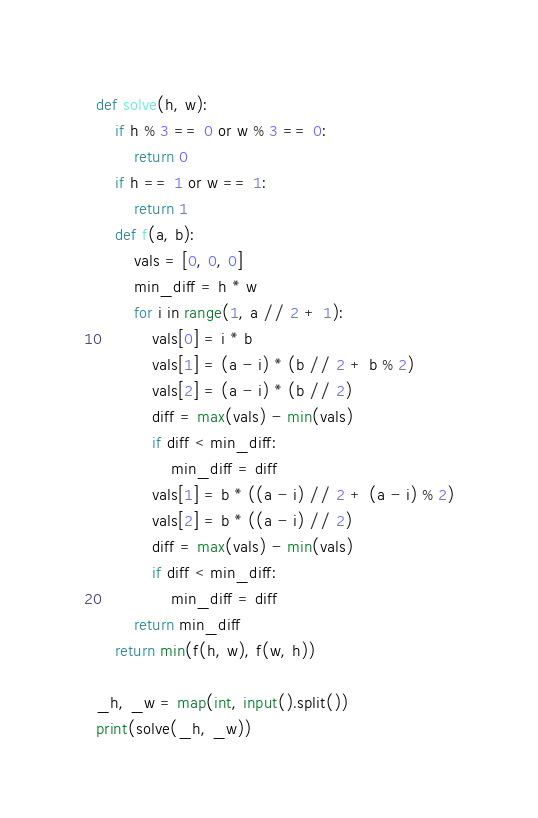<code> <loc_0><loc_0><loc_500><loc_500><_Python_>def solve(h, w):
    if h % 3 == 0 or w % 3 == 0:
        return 0
    if h == 1 or w == 1:
        return 1
    def f(a, b):
        vals = [0, 0, 0]
        min_diff = h * w
        for i in range(1, a // 2 + 1):
            vals[0] = i * b
            vals[1] = (a - i) * (b // 2 + b % 2)
            vals[2] = (a - i) * (b // 2)
            diff = max(vals) - min(vals)
            if diff < min_diff:
                min_diff = diff
            vals[1] = b * ((a - i) // 2 + (a - i) % 2)
            vals[2] = b * ((a - i) // 2)
            diff = max(vals) - min(vals)
            if diff < min_diff:
                min_diff = diff
        return min_diff
    return min(f(h, w), f(w, h))

_h, _w = map(int, input().split())
print(solve(_h, _w))
</code> 